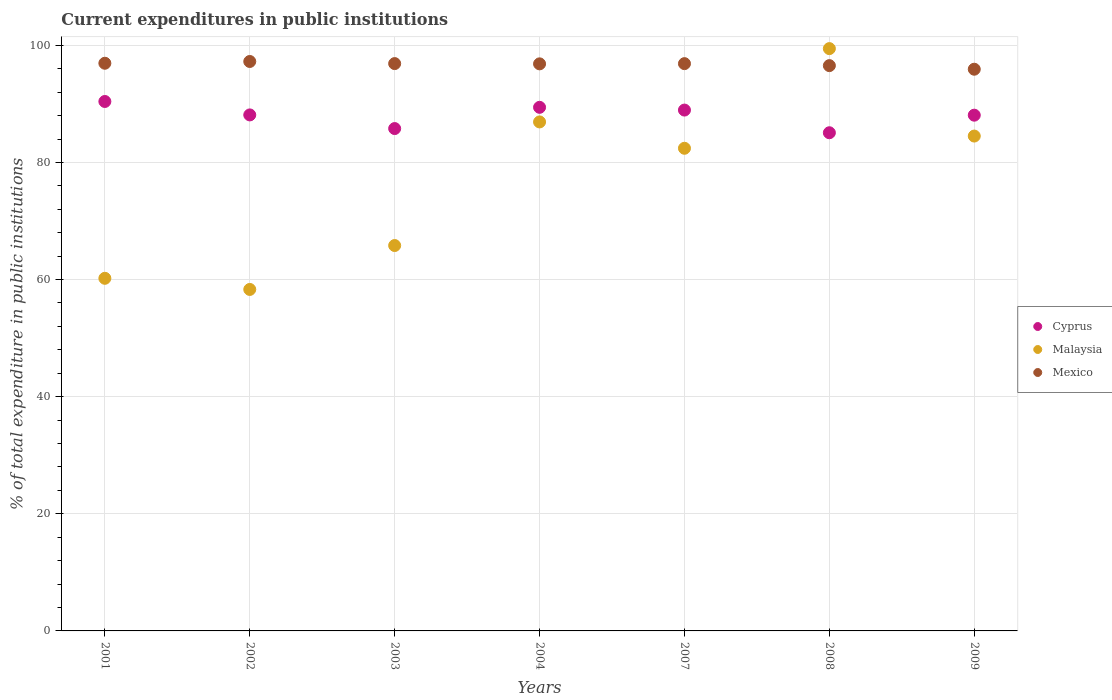How many different coloured dotlines are there?
Give a very brief answer. 3. Is the number of dotlines equal to the number of legend labels?
Provide a succinct answer. Yes. What is the current expenditures in public institutions in Mexico in 2002?
Offer a very short reply. 97.24. Across all years, what is the maximum current expenditures in public institutions in Mexico?
Your response must be concise. 97.24. Across all years, what is the minimum current expenditures in public institutions in Mexico?
Make the answer very short. 95.92. In which year was the current expenditures in public institutions in Malaysia minimum?
Keep it short and to the point. 2002. What is the total current expenditures in public institutions in Malaysia in the graph?
Your answer should be compact. 537.61. What is the difference between the current expenditures in public institutions in Mexico in 2001 and that in 2003?
Your answer should be very brief. 0.06. What is the difference between the current expenditures in public institutions in Mexico in 2004 and the current expenditures in public institutions in Malaysia in 2003?
Your answer should be compact. 31.02. What is the average current expenditures in public institutions in Mexico per year?
Keep it short and to the point. 96.74. In the year 2003, what is the difference between the current expenditures in public institutions in Cyprus and current expenditures in public institutions in Malaysia?
Your answer should be very brief. 19.97. In how many years, is the current expenditures in public institutions in Mexico greater than 56 %?
Offer a very short reply. 7. What is the ratio of the current expenditures in public institutions in Cyprus in 2007 to that in 2009?
Your response must be concise. 1.01. Is the current expenditures in public institutions in Malaysia in 2004 less than that in 2008?
Your response must be concise. Yes. Is the difference between the current expenditures in public institutions in Cyprus in 2003 and 2007 greater than the difference between the current expenditures in public institutions in Malaysia in 2003 and 2007?
Provide a short and direct response. Yes. What is the difference between the highest and the second highest current expenditures in public institutions in Mexico?
Offer a very short reply. 0.3. What is the difference between the highest and the lowest current expenditures in public institutions in Malaysia?
Offer a terse response. 41.12. Is the sum of the current expenditures in public institutions in Malaysia in 2002 and 2009 greater than the maximum current expenditures in public institutions in Mexico across all years?
Keep it short and to the point. Yes. Is the current expenditures in public institutions in Cyprus strictly greater than the current expenditures in public institutions in Malaysia over the years?
Provide a succinct answer. No. Is the current expenditures in public institutions in Cyprus strictly less than the current expenditures in public institutions in Mexico over the years?
Offer a terse response. Yes. How many years are there in the graph?
Your answer should be compact. 7. What is the difference between two consecutive major ticks on the Y-axis?
Offer a terse response. 20. Does the graph contain any zero values?
Make the answer very short. No. Does the graph contain grids?
Make the answer very short. Yes. Where does the legend appear in the graph?
Your answer should be compact. Center right. How many legend labels are there?
Your answer should be compact. 3. What is the title of the graph?
Ensure brevity in your answer.  Current expenditures in public institutions. What is the label or title of the Y-axis?
Provide a short and direct response. % of total expenditure in public institutions. What is the % of total expenditure in public institutions in Cyprus in 2001?
Make the answer very short. 90.41. What is the % of total expenditure in public institutions in Malaysia in 2001?
Provide a succinct answer. 60.21. What is the % of total expenditure in public institutions in Mexico in 2001?
Offer a terse response. 96.94. What is the % of total expenditure in public institutions of Cyprus in 2002?
Your response must be concise. 88.11. What is the % of total expenditure in public institutions of Malaysia in 2002?
Your answer should be very brief. 58.31. What is the % of total expenditure in public institutions of Mexico in 2002?
Your answer should be very brief. 97.24. What is the % of total expenditure in public institutions in Cyprus in 2003?
Give a very brief answer. 85.78. What is the % of total expenditure in public institutions of Malaysia in 2003?
Your response must be concise. 65.81. What is the % of total expenditure in public institutions in Mexico in 2003?
Ensure brevity in your answer.  96.88. What is the % of total expenditure in public institutions in Cyprus in 2004?
Make the answer very short. 89.41. What is the % of total expenditure in public institutions of Malaysia in 2004?
Your answer should be very brief. 86.92. What is the % of total expenditure in public institutions of Mexico in 2004?
Your response must be concise. 96.83. What is the % of total expenditure in public institutions of Cyprus in 2007?
Offer a terse response. 88.94. What is the % of total expenditure in public institutions of Malaysia in 2007?
Offer a very short reply. 82.42. What is the % of total expenditure in public institutions of Mexico in 2007?
Ensure brevity in your answer.  96.87. What is the % of total expenditure in public institutions of Cyprus in 2008?
Provide a succinct answer. 85.07. What is the % of total expenditure in public institutions of Malaysia in 2008?
Provide a short and direct response. 99.44. What is the % of total expenditure in public institutions of Mexico in 2008?
Provide a short and direct response. 96.53. What is the % of total expenditure in public institutions of Cyprus in 2009?
Your answer should be compact. 88.07. What is the % of total expenditure in public institutions in Malaysia in 2009?
Provide a succinct answer. 84.5. What is the % of total expenditure in public institutions in Mexico in 2009?
Provide a short and direct response. 95.92. Across all years, what is the maximum % of total expenditure in public institutions of Cyprus?
Provide a succinct answer. 90.41. Across all years, what is the maximum % of total expenditure in public institutions in Malaysia?
Offer a very short reply. 99.44. Across all years, what is the maximum % of total expenditure in public institutions in Mexico?
Offer a terse response. 97.24. Across all years, what is the minimum % of total expenditure in public institutions in Cyprus?
Keep it short and to the point. 85.07. Across all years, what is the minimum % of total expenditure in public institutions in Malaysia?
Give a very brief answer. 58.31. Across all years, what is the minimum % of total expenditure in public institutions in Mexico?
Give a very brief answer. 95.92. What is the total % of total expenditure in public institutions of Cyprus in the graph?
Your answer should be very brief. 615.8. What is the total % of total expenditure in public institutions of Malaysia in the graph?
Your answer should be very brief. 537.61. What is the total % of total expenditure in public institutions of Mexico in the graph?
Offer a terse response. 677.21. What is the difference between the % of total expenditure in public institutions in Cyprus in 2001 and that in 2002?
Offer a very short reply. 2.29. What is the difference between the % of total expenditure in public institutions in Malaysia in 2001 and that in 2002?
Your answer should be compact. 1.9. What is the difference between the % of total expenditure in public institutions of Mexico in 2001 and that in 2002?
Keep it short and to the point. -0.3. What is the difference between the % of total expenditure in public institutions of Cyprus in 2001 and that in 2003?
Give a very brief answer. 4.62. What is the difference between the % of total expenditure in public institutions in Malaysia in 2001 and that in 2003?
Ensure brevity in your answer.  -5.6. What is the difference between the % of total expenditure in public institutions of Mexico in 2001 and that in 2003?
Keep it short and to the point. 0.06. What is the difference between the % of total expenditure in public institutions of Cyprus in 2001 and that in 2004?
Ensure brevity in your answer.  1. What is the difference between the % of total expenditure in public institutions of Malaysia in 2001 and that in 2004?
Your answer should be very brief. -26.7. What is the difference between the % of total expenditure in public institutions in Mexico in 2001 and that in 2004?
Provide a succinct answer. 0.1. What is the difference between the % of total expenditure in public institutions in Cyprus in 2001 and that in 2007?
Make the answer very short. 1.47. What is the difference between the % of total expenditure in public institutions of Malaysia in 2001 and that in 2007?
Your response must be concise. -22.21. What is the difference between the % of total expenditure in public institutions of Mexico in 2001 and that in 2007?
Your response must be concise. 0.07. What is the difference between the % of total expenditure in public institutions of Cyprus in 2001 and that in 2008?
Make the answer very short. 5.34. What is the difference between the % of total expenditure in public institutions in Malaysia in 2001 and that in 2008?
Make the answer very short. -39.22. What is the difference between the % of total expenditure in public institutions in Mexico in 2001 and that in 2008?
Give a very brief answer. 0.41. What is the difference between the % of total expenditure in public institutions in Cyprus in 2001 and that in 2009?
Offer a terse response. 2.34. What is the difference between the % of total expenditure in public institutions of Malaysia in 2001 and that in 2009?
Provide a succinct answer. -24.29. What is the difference between the % of total expenditure in public institutions in Mexico in 2001 and that in 2009?
Provide a succinct answer. 1.02. What is the difference between the % of total expenditure in public institutions of Cyprus in 2002 and that in 2003?
Your response must be concise. 2.33. What is the difference between the % of total expenditure in public institutions in Malaysia in 2002 and that in 2003?
Provide a succinct answer. -7.5. What is the difference between the % of total expenditure in public institutions in Mexico in 2002 and that in 2003?
Provide a succinct answer. 0.36. What is the difference between the % of total expenditure in public institutions of Cyprus in 2002 and that in 2004?
Your response must be concise. -1.3. What is the difference between the % of total expenditure in public institutions of Malaysia in 2002 and that in 2004?
Make the answer very short. -28.6. What is the difference between the % of total expenditure in public institutions in Mexico in 2002 and that in 2004?
Ensure brevity in your answer.  0.4. What is the difference between the % of total expenditure in public institutions in Cyprus in 2002 and that in 2007?
Your answer should be compact. -0.83. What is the difference between the % of total expenditure in public institutions in Malaysia in 2002 and that in 2007?
Make the answer very short. -24.11. What is the difference between the % of total expenditure in public institutions in Mexico in 2002 and that in 2007?
Make the answer very short. 0.37. What is the difference between the % of total expenditure in public institutions in Cyprus in 2002 and that in 2008?
Offer a very short reply. 3.04. What is the difference between the % of total expenditure in public institutions in Malaysia in 2002 and that in 2008?
Provide a short and direct response. -41.12. What is the difference between the % of total expenditure in public institutions in Mexico in 2002 and that in 2008?
Make the answer very short. 0.71. What is the difference between the % of total expenditure in public institutions of Cyprus in 2002 and that in 2009?
Your answer should be compact. 0.04. What is the difference between the % of total expenditure in public institutions of Malaysia in 2002 and that in 2009?
Provide a succinct answer. -26.19. What is the difference between the % of total expenditure in public institutions in Mexico in 2002 and that in 2009?
Your response must be concise. 1.32. What is the difference between the % of total expenditure in public institutions of Cyprus in 2003 and that in 2004?
Offer a very short reply. -3.63. What is the difference between the % of total expenditure in public institutions in Malaysia in 2003 and that in 2004?
Provide a succinct answer. -21.11. What is the difference between the % of total expenditure in public institutions of Mexico in 2003 and that in 2004?
Your answer should be compact. 0.04. What is the difference between the % of total expenditure in public institutions of Cyprus in 2003 and that in 2007?
Your answer should be compact. -3.16. What is the difference between the % of total expenditure in public institutions in Malaysia in 2003 and that in 2007?
Make the answer very short. -16.61. What is the difference between the % of total expenditure in public institutions in Mexico in 2003 and that in 2007?
Your response must be concise. 0.01. What is the difference between the % of total expenditure in public institutions in Cyprus in 2003 and that in 2008?
Provide a succinct answer. 0.72. What is the difference between the % of total expenditure in public institutions in Malaysia in 2003 and that in 2008?
Your answer should be compact. -33.63. What is the difference between the % of total expenditure in public institutions in Mexico in 2003 and that in 2008?
Make the answer very short. 0.35. What is the difference between the % of total expenditure in public institutions of Cyprus in 2003 and that in 2009?
Keep it short and to the point. -2.29. What is the difference between the % of total expenditure in public institutions in Malaysia in 2003 and that in 2009?
Keep it short and to the point. -18.69. What is the difference between the % of total expenditure in public institutions of Mexico in 2003 and that in 2009?
Keep it short and to the point. 0.96. What is the difference between the % of total expenditure in public institutions of Cyprus in 2004 and that in 2007?
Keep it short and to the point. 0.47. What is the difference between the % of total expenditure in public institutions in Malaysia in 2004 and that in 2007?
Offer a terse response. 4.5. What is the difference between the % of total expenditure in public institutions of Mexico in 2004 and that in 2007?
Ensure brevity in your answer.  -0.04. What is the difference between the % of total expenditure in public institutions of Cyprus in 2004 and that in 2008?
Ensure brevity in your answer.  4.34. What is the difference between the % of total expenditure in public institutions in Malaysia in 2004 and that in 2008?
Your answer should be compact. -12.52. What is the difference between the % of total expenditure in public institutions in Mexico in 2004 and that in 2008?
Ensure brevity in your answer.  0.3. What is the difference between the % of total expenditure in public institutions in Cyprus in 2004 and that in 2009?
Offer a terse response. 1.34. What is the difference between the % of total expenditure in public institutions in Malaysia in 2004 and that in 2009?
Keep it short and to the point. 2.41. What is the difference between the % of total expenditure in public institutions in Mexico in 2004 and that in 2009?
Provide a succinct answer. 0.92. What is the difference between the % of total expenditure in public institutions in Cyprus in 2007 and that in 2008?
Make the answer very short. 3.87. What is the difference between the % of total expenditure in public institutions in Malaysia in 2007 and that in 2008?
Provide a succinct answer. -17.02. What is the difference between the % of total expenditure in public institutions of Mexico in 2007 and that in 2008?
Offer a very short reply. 0.34. What is the difference between the % of total expenditure in public institutions of Cyprus in 2007 and that in 2009?
Provide a succinct answer. 0.87. What is the difference between the % of total expenditure in public institutions in Malaysia in 2007 and that in 2009?
Your answer should be compact. -2.09. What is the difference between the % of total expenditure in public institutions in Mexico in 2007 and that in 2009?
Provide a short and direct response. 0.95. What is the difference between the % of total expenditure in public institutions in Cyprus in 2008 and that in 2009?
Give a very brief answer. -3. What is the difference between the % of total expenditure in public institutions in Malaysia in 2008 and that in 2009?
Provide a succinct answer. 14.93. What is the difference between the % of total expenditure in public institutions in Mexico in 2008 and that in 2009?
Ensure brevity in your answer.  0.61. What is the difference between the % of total expenditure in public institutions of Cyprus in 2001 and the % of total expenditure in public institutions of Malaysia in 2002?
Your response must be concise. 32.1. What is the difference between the % of total expenditure in public institutions in Cyprus in 2001 and the % of total expenditure in public institutions in Mexico in 2002?
Ensure brevity in your answer.  -6.83. What is the difference between the % of total expenditure in public institutions of Malaysia in 2001 and the % of total expenditure in public institutions of Mexico in 2002?
Provide a short and direct response. -37.03. What is the difference between the % of total expenditure in public institutions of Cyprus in 2001 and the % of total expenditure in public institutions of Malaysia in 2003?
Offer a terse response. 24.6. What is the difference between the % of total expenditure in public institutions in Cyprus in 2001 and the % of total expenditure in public institutions in Mexico in 2003?
Provide a succinct answer. -6.47. What is the difference between the % of total expenditure in public institutions in Malaysia in 2001 and the % of total expenditure in public institutions in Mexico in 2003?
Your response must be concise. -36.67. What is the difference between the % of total expenditure in public institutions in Cyprus in 2001 and the % of total expenditure in public institutions in Malaysia in 2004?
Offer a very short reply. 3.49. What is the difference between the % of total expenditure in public institutions of Cyprus in 2001 and the % of total expenditure in public institutions of Mexico in 2004?
Your answer should be compact. -6.43. What is the difference between the % of total expenditure in public institutions in Malaysia in 2001 and the % of total expenditure in public institutions in Mexico in 2004?
Ensure brevity in your answer.  -36.62. What is the difference between the % of total expenditure in public institutions of Cyprus in 2001 and the % of total expenditure in public institutions of Malaysia in 2007?
Your answer should be compact. 7.99. What is the difference between the % of total expenditure in public institutions in Cyprus in 2001 and the % of total expenditure in public institutions in Mexico in 2007?
Keep it short and to the point. -6.46. What is the difference between the % of total expenditure in public institutions of Malaysia in 2001 and the % of total expenditure in public institutions of Mexico in 2007?
Your response must be concise. -36.66. What is the difference between the % of total expenditure in public institutions in Cyprus in 2001 and the % of total expenditure in public institutions in Malaysia in 2008?
Provide a succinct answer. -9.03. What is the difference between the % of total expenditure in public institutions of Cyprus in 2001 and the % of total expenditure in public institutions of Mexico in 2008?
Ensure brevity in your answer.  -6.12. What is the difference between the % of total expenditure in public institutions in Malaysia in 2001 and the % of total expenditure in public institutions in Mexico in 2008?
Offer a very short reply. -36.32. What is the difference between the % of total expenditure in public institutions in Cyprus in 2001 and the % of total expenditure in public institutions in Malaysia in 2009?
Keep it short and to the point. 5.9. What is the difference between the % of total expenditure in public institutions in Cyprus in 2001 and the % of total expenditure in public institutions in Mexico in 2009?
Your answer should be very brief. -5.51. What is the difference between the % of total expenditure in public institutions in Malaysia in 2001 and the % of total expenditure in public institutions in Mexico in 2009?
Keep it short and to the point. -35.7. What is the difference between the % of total expenditure in public institutions in Cyprus in 2002 and the % of total expenditure in public institutions in Malaysia in 2003?
Keep it short and to the point. 22.3. What is the difference between the % of total expenditure in public institutions of Cyprus in 2002 and the % of total expenditure in public institutions of Mexico in 2003?
Ensure brevity in your answer.  -8.76. What is the difference between the % of total expenditure in public institutions of Malaysia in 2002 and the % of total expenditure in public institutions of Mexico in 2003?
Your answer should be compact. -38.57. What is the difference between the % of total expenditure in public institutions in Cyprus in 2002 and the % of total expenditure in public institutions in Malaysia in 2004?
Your response must be concise. 1.2. What is the difference between the % of total expenditure in public institutions in Cyprus in 2002 and the % of total expenditure in public institutions in Mexico in 2004?
Your answer should be very brief. -8.72. What is the difference between the % of total expenditure in public institutions in Malaysia in 2002 and the % of total expenditure in public institutions in Mexico in 2004?
Your answer should be compact. -38.52. What is the difference between the % of total expenditure in public institutions in Cyprus in 2002 and the % of total expenditure in public institutions in Malaysia in 2007?
Your answer should be very brief. 5.7. What is the difference between the % of total expenditure in public institutions in Cyprus in 2002 and the % of total expenditure in public institutions in Mexico in 2007?
Ensure brevity in your answer.  -8.76. What is the difference between the % of total expenditure in public institutions in Malaysia in 2002 and the % of total expenditure in public institutions in Mexico in 2007?
Give a very brief answer. -38.56. What is the difference between the % of total expenditure in public institutions in Cyprus in 2002 and the % of total expenditure in public institutions in Malaysia in 2008?
Make the answer very short. -11.32. What is the difference between the % of total expenditure in public institutions of Cyprus in 2002 and the % of total expenditure in public institutions of Mexico in 2008?
Ensure brevity in your answer.  -8.42. What is the difference between the % of total expenditure in public institutions of Malaysia in 2002 and the % of total expenditure in public institutions of Mexico in 2008?
Keep it short and to the point. -38.22. What is the difference between the % of total expenditure in public institutions in Cyprus in 2002 and the % of total expenditure in public institutions in Malaysia in 2009?
Your answer should be compact. 3.61. What is the difference between the % of total expenditure in public institutions in Cyprus in 2002 and the % of total expenditure in public institutions in Mexico in 2009?
Offer a very short reply. -7.8. What is the difference between the % of total expenditure in public institutions in Malaysia in 2002 and the % of total expenditure in public institutions in Mexico in 2009?
Offer a very short reply. -37.61. What is the difference between the % of total expenditure in public institutions in Cyprus in 2003 and the % of total expenditure in public institutions in Malaysia in 2004?
Provide a succinct answer. -1.13. What is the difference between the % of total expenditure in public institutions in Cyprus in 2003 and the % of total expenditure in public institutions in Mexico in 2004?
Ensure brevity in your answer.  -11.05. What is the difference between the % of total expenditure in public institutions of Malaysia in 2003 and the % of total expenditure in public institutions of Mexico in 2004?
Make the answer very short. -31.02. What is the difference between the % of total expenditure in public institutions of Cyprus in 2003 and the % of total expenditure in public institutions of Malaysia in 2007?
Offer a very short reply. 3.37. What is the difference between the % of total expenditure in public institutions in Cyprus in 2003 and the % of total expenditure in public institutions in Mexico in 2007?
Offer a terse response. -11.09. What is the difference between the % of total expenditure in public institutions in Malaysia in 2003 and the % of total expenditure in public institutions in Mexico in 2007?
Keep it short and to the point. -31.06. What is the difference between the % of total expenditure in public institutions in Cyprus in 2003 and the % of total expenditure in public institutions in Malaysia in 2008?
Your answer should be compact. -13.65. What is the difference between the % of total expenditure in public institutions of Cyprus in 2003 and the % of total expenditure in public institutions of Mexico in 2008?
Your answer should be very brief. -10.75. What is the difference between the % of total expenditure in public institutions of Malaysia in 2003 and the % of total expenditure in public institutions of Mexico in 2008?
Offer a terse response. -30.72. What is the difference between the % of total expenditure in public institutions of Cyprus in 2003 and the % of total expenditure in public institutions of Malaysia in 2009?
Offer a very short reply. 1.28. What is the difference between the % of total expenditure in public institutions in Cyprus in 2003 and the % of total expenditure in public institutions in Mexico in 2009?
Keep it short and to the point. -10.13. What is the difference between the % of total expenditure in public institutions in Malaysia in 2003 and the % of total expenditure in public institutions in Mexico in 2009?
Offer a very short reply. -30.11. What is the difference between the % of total expenditure in public institutions in Cyprus in 2004 and the % of total expenditure in public institutions in Malaysia in 2007?
Give a very brief answer. 6.99. What is the difference between the % of total expenditure in public institutions in Cyprus in 2004 and the % of total expenditure in public institutions in Mexico in 2007?
Ensure brevity in your answer.  -7.46. What is the difference between the % of total expenditure in public institutions in Malaysia in 2004 and the % of total expenditure in public institutions in Mexico in 2007?
Your response must be concise. -9.95. What is the difference between the % of total expenditure in public institutions of Cyprus in 2004 and the % of total expenditure in public institutions of Malaysia in 2008?
Your answer should be compact. -10.03. What is the difference between the % of total expenditure in public institutions in Cyprus in 2004 and the % of total expenditure in public institutions in Mexico in 2008?
Give a very brief answer. -7.12. What is the difference between the % of total expenditure in public institutions in Malaysia in 2004 and the % of total expenditure in public institutions in Mexico in 2008?
Keep it short and to the point. -9.61. What is the difference between the % of total expenditure in public institutions of Cyprus in 2004 and the % of total expenditure in public institutions of Malaysia in 2009?
Give a very brief answer. 4.91. What is the difference between the % of total expenditure in public institutions of Cyprus in 2004 and the % of total expenditure in public institutions of Mexico in 2009?
Provide a short and direct response. -6.51. What is the difference between the % of total expenditure in public institutions of Malaysia in 2004 and the % of total expenditure in public institutions of Mexico in 2009?
Offer a very short reply. -9. What is the difference between the % of total expenditure in public institutions of Cyprus in 2007 and the % of total expenditure in public institutions of Malaysia in 2008?
Your answer should be very brief. -10.49. What is the difference between the % of total expenditure in public institutions in Cyprus in 2007 and the % of total expenditure in public institutions in Mexico in 2008?
Your response must be concise. -7.59. What is the difference between the % of total expenditure in public institutions in Malaysia in 2007 and the % of total expenditure in public institutions in Mexico in 2008?
Keep it short and to the point. -14.11. What is the difference between the % of total expenditure in public institutions in Cyprus in 2007 and the % of total expenditure in public institutions in Malaysia in 2009?
Your answer should be compact. 4.44. What is the difference between the % of total expenditure in public institutions of Cyprus in 2007 and the % of total expenditure in public institutions of Mexico in 2009?
Your answer should be compact. -6.98. What is the difference between the % of total expenditure in public institutions in Malaysia in 2007 and the % of total expenditure in public institutions in Mexico in 2009?
Provide a succinct answer. -13.5. What is the difference between the % of total expenditure in public institutions of Cyprus in 2008 and the % of total expenditure in public institutions of Malaysia in 2009?
Offer a very short reply. 0.57. What is the difference between the % of total expenditure in public institutions in Cyprus in 2008 and the % of total expenditure in public institutions in Mexico in 2009?
Keep it short and to the point. -10.85. What is the difference between the % of total expenditure in public institutions of Malaysia in 2008 and the % of total expenditure in public institutions of Mexico in 2009?
Make the answer very short. 3.52. What is the average % of total expenditure in public institutions of Cyprus per year?
Your response must be concise. 87.97. What is the average % of total expenditure in public institutions in Malaysia per year?
Give a very brief answer. 76.8. What is the average % of total expenditure in public institutions in Mexico per year?
Make the answer very short. 96.74. In the year 2001, what is the difference between the % of total expenditure in public institutions of Cyprus and % of total expenditure in public institutions of Malaysia?
Your answer should be compact. 30.2. In the year 2001, what is the difference between the % of total expenditure in public institutions in Cyprus and % of total expenditure in public institutions in Mexico?
Offer a terse response. -6.53. In the year 2001, what is the difference between the % of total expenditure in public institutions in Malaysia and % of total expenditure in public institutions in Mexico?
Give a very brief answer. -36.72. In the year 2002, what is the difference between the % of total expenditure in public institutions in Cyprus and % of total expenditure in public institutions in Malaysia?
Your answer should be compact. 29.8. In the year 2002, what is the difference between the % of total expenditure in public institutions in Cyprus and % of total expenditure in public institutions in Mexico?
Your answer should be compact. -9.12. In the year 2002, what is the difference between the % of total expenditure in public institutions of Malaysia and % of total expenditure in public institutions of Mexico?
Make the answer very short. -38.93. In the year 2003, what is the difference between the % of total expenditure in public institutions in Cyprus and % of total expenditure in public institutions in Malaysia?
Provide a short and direct response. 19.97. In the year 2003, what is the difference between the % of total expenditure in public institutions of Cyprus and % of total expenditure in public institutions of Mexico?
Keep it short and to the point. -11.09. In the year 2003, what is the difference between the % of total expenditure in public institutions of Malaysia and % of total expenditure in public institutions of Mexico?
Make the answer very short. -31.07. In the year 2004, what is the difference between the % of total expenditure in public institutions in Cyprus and % of total expenditure in public institutions in Malaysia?
Keep it short and to the point. 2.49. In the year 2004, what is the difference between the % of total expenditure in public institutions in Cyprus and % of total expenditure in public institutions in Mexico?
Give a very brief answer. -7.42. In the year 2004, what is the difference between the % of total expenditure in public institutions in Malaysia and % of total expenditure in public institutions in Mexico?
Your answer should be compact. -9.92. In the year 2007, what is the difference between the % of total expenditure in public institutions in Cyprus and % of total expenditure in public institutions in Malaysia?
Offer a very short reply. 6.52. In the year 2007, what is the difference between the % of total expenditure in public institutions of Cyprus and % of total expenditure in public institutions of Mexico?
Provide a succinct answer. -7.93. In the year 2007, what is the difference between the % of total expenditure in public institutions in Malaysia and % of total expenditure in public institutions in Mexico?
Give a very brief answer. -14.45. In the year 2008, what is the difference between the % of total expenditure in public institutions in Cyprus and % of total expenditure in public institutions in Malaysia?
Offer a terse response. -14.37. In the year 2008, what is the difference between the % of total expenditure in public institutions of Cyprus and % of total expenditure in public institutions of Mexico?
Keep it short and to the point. -11.46. In the year 2008, what is the difference between the % of total expenditure in public institutions of Malaysia and % of total expenditure in public institutions of Mexico?
Your answer should be very brief. 2.9. In the year 2009, what is the difference between the % of total expenditure in public institutions in Cyprus and % of total expenditure in public institutions in Malaysia?
Offer a very short reply. 3.57. In the year 2009, what is the difference between the % of total expenditure in public institutions of Cyprus and % of total expenditure in public institutions of Mexico?
Provide a succinct answer. -7.85. In the year 2009, what is the difference between the % of total expenditure in public institutions of Malaysia and % of total expenditure in public institutions of Mexico?
Ensure brevity in your answer.  -11.41. What is the ratio of the % of total expenditure in public institutions in Malaysia in 2001 to that in 2002?
Your answer should be very brief. 1.03. What is the ratio of the % of total expenditure in public institutions in Mexico in 2001 to that in 2002?
Make the answer very short. 1. What is the ratio of the % of total expenditure in public institutions in Cyprus in 2001 to that in 2003?
Your response must be concise. 1.05. What is the ratio of the % of total expenditure in public institutions in Malaysia in 2001 to that in 2003?
Offer a very short reply. 0.91. What is the ratio of the % of total expenditure in public institutions of Mexico in 2001 to that in 2003?
Provide a succinct answer. 1. What is the ratio of the % of total expenditure in public institutions of Cyprus in 2001 to that in 2004?
Give a very brief answer. 1.01. What is the ratio of the % of total expenditure in public institutions of Malaysia in 2001 to that in 2004?
Make the answer very short. 0.69. What is the ratio of the % of total expenditure in public institutions of Mexico in 2001 to that in 2004?
Your answer should be very brief. 1. What is the ratio of the % of total expenditure in public institutions in Cyprus in 2001 to that in 2007?
Make the answer very short. 1.02. What is the ratio of the % of total expenditure in public institutions in Malaysia in 2001 to that in 2007?
Your answer should be very brief. 0.73. What is the ratio of the % of total expenditure in public institutions of Cyprus in 2001 to that in 2008?
Your response must be concise. 1.06. What is the ratio of the % of total expenditure in public institutions in Malaysia in 2001 to that in 2008?
Make the answer very short. 0.61. What is the ratio of the % of total expenditure in public institutions in Cyprus in 2001 to that in 2009?
Make the answer very short. 1.03. What is the ratio of the % of total expenditure in public institutions in Malaysia in 2001 to that in 2009?
Make the answer very short. 0.71. What is the ratio of the % of total expenditure in public institutions of Mexico in 2001 to that in 2009?
Your answer should be compact. 1.01. What is the ratio of the % of total expenditure in public institutions in Cyprus in 2002 to that in 2003?
Provide a short and direct response. 1.03. What is the ratio of the % of total expenditure in public institutions in Malaysia in 2002 to that in 2003?
Your answer should be compact. 0.89. What is the ratio of the % of total expenditure in public institutions in Mexico in 2002 to that in 2003?
Your answer should be very brief. 1. What is the ratio of the % of total expenditure in public institutions of Cyprus in 2002 to that in 2004?
Ensure brevity in your answer.  0.99. What is the ratio of the % of total expenditure in public institutions of Malaysia in 2002 to that in 2004?
Ensure brevity in your answer.  0.67. What is the ratio of the % of total expenditure in public institutions in Cyprus in 2002 to that in 2007?
Offer a terse response. 0.99. What is the ratio of the % of total expenditure in public institutions of Malaysia in 2002 to that in 2007?
Provide a short and direct response. 0.71. What is the ratio of the % of total expenditure in public institutions of Cyprus in 2002 to that in 2008?
Offer a terse response. 1.04. What is the ratio of the % of total expenditure in public institutions in Malaysia in 2002 to that in 2008?
Give a very brief answer. 0.59. What is the ratio of the % of total expenditure in public institutions of Mexico in 2002 to that in 2008?
Make the answer very short. 1.01. What is the ratio of the % of total expenditure in public institutions of Cyprus in 2002 to that in 2009?
Give a very brief answer. 1. What is the ratio of the % of total expenditure in public institutions in Malaysia in 2002 to that in 2009?
Keep it short and to the point. 0.69. What is the ratio of the % of total expenditure in public institutions of Mexico in 2002 to that in 2009?
Your answer should be very brief. 1.01. What is the ratio of the % of total expenditure in public institutions in Cyprus in 2003 to that in 2004?
Ensure brevity in your answer.  0.96. What is the ratio of the % of total expenditure in public institutions in Malaysia in 2003 to that in 2004?
Keep it short and to the point. 0.76. What is the ratio of the % of total expenditure in public institutions of Cyprus in 2003 to that in 2007?
Provide a short and direct response. 0.96. What is the ratio of the % of total expenditure in public institutions of Malaysia in 2003 to that in 2007?
Offer a terse response. 0.8. What is the ratio of the % of total expenditure in public institutions in Cyprus in 2003 to that in 2008?
Offer a very short reply. 1.01. What is the ratio of the % of total expenditure in public institutions in Malaysia in 2003 to that in 2008?
Your answer should be compact. 0.66. What is the ratio of the % of total expenditure in public institutions of Mexico in 2003 to that in 2008?
Offer a terse response. 1. What is the ratio of the % of total expenditure in public institutions in Cyprus in 2003 to that in 2009?
Your answer should be very brief. 0.97. What is the ratio of the % of total expenditure in public institutions in Malaysia in 2003 to that in 2009?
Give a very brief answer. 0.78. What is the ratio of the % of total expenditure in public institutions in Mexico in 2003 to that in 2009?
Offer a very short reply. 1.01. What is the ratio of the % of total expenditure in public institutions of Malaysia in 2004 to that in 2007?
Give a very brief answer. 1.05. What is the ratio of the % of total expenditure in public institutions in Mexico in 2004 to that in 2007?
Provide a short and direct response. 1. What is the ratio of the % of total expenditure in public institutions of Cyprus in 2004 to that in 2008?
Provide a short and direct response. 1.05. What is the ratio of the % of total expenditure in public institutions of Malaysia in 2004 to that in 2008?
Your answer should be very brief. 0.87. What is the ratio of the % of total expenditure in public institutions of Cyprus in 2004 to that in 2009?
Give a very brief answer. 1.02. What is the ratio of the % of total expenditure in public institutions in Malaysia in 2004 to that in 2009?
Offer a very short reply. 1.03. What is the ratio of the % of total expenditure in public institutions in Mexico in 2004 to that in 2009?
Your answer should be very brief. 1.01. What is the ratio of the % of total expenditure in public institutions in Cyprus in 2007 to that in 2008?
Offer a very short reply. 1.05. What is the ratio of the % of total expenditure in public institutions in Malaysia in 2007 to that in 2008?
Provide a short and direct response. 0.83. What is the ratio of the % of total expenditure in public institutions in Cyprus in 2007 to that in 2009?
Make the answer very short. 1.01. What is the ratio of the % of total expenditure in public institutions of Malaysia in 2007 to that in 2009?
Your answer should be compact. 0.98. What is the ratio of the % of total expenditure in public institutions in Mexico in 2007 to that in 2009?
Provide a succinct answer. 1.01. What is the ratio of the % of total expenditure in public institutions of Cyprus in 2008 to that in 2009?
Offer a very short reply. 0.97. What is the ratio of the % of total expenditure in public institutions in Malaysia in 2008 to that in 2009?
Give a very brief answer. 1.18. What is the ratio of the % of total expenditure in public institutions of Mexico in 2008 to that in 2009?
Provide a succinct answer. 1.01. What is the difference between the highest and the second highest % of total expenditure in public institutions in Malaysia?
Your answer should be compact. 12.52. What is the difference between the highest and the second highest % of total expenditure in public institutions in Mexico?
Offer a terse response. 0.3. What is the difference between the highest and the lowest % of total expenditure in public institutions in Cyprus?
Your answer should be very brief. 5.34. What is the difference between the highest and the lowest % of total expenditure in public institutions in Malaysia?
Give a very brief answer. 41.12. What is the difference between the highest and the lowest % of total expenditure in public institutions of Mexico?
Ensure brevity in your answer.  1.32. 